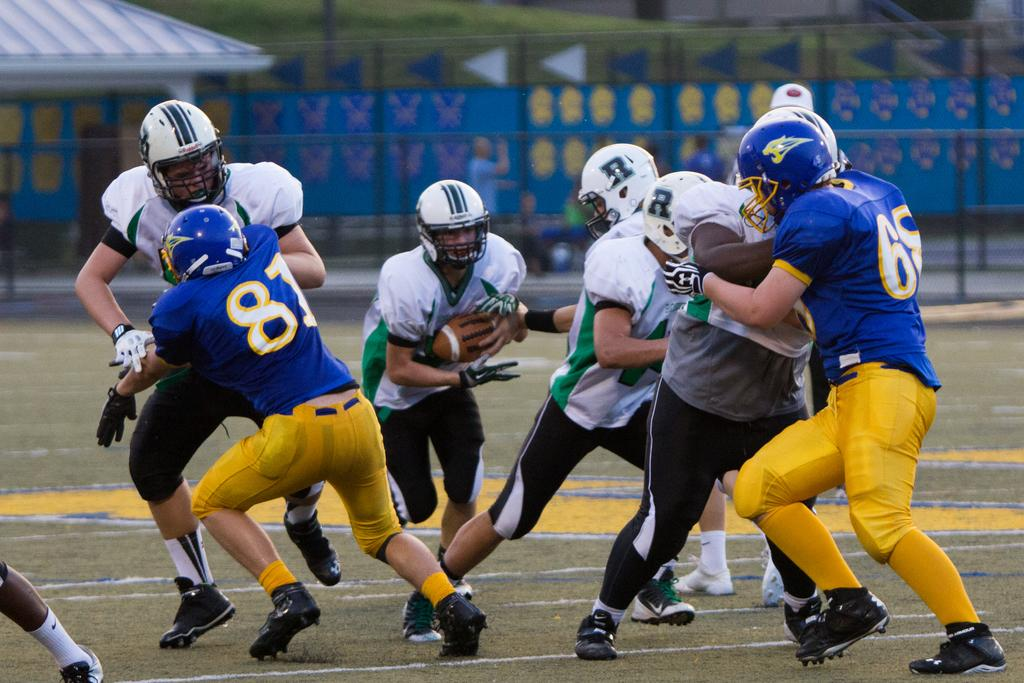What is happening on the ground in the image? There are players on the ground in the image. What can be seen in the distance behind the players? There is a house and fencing in the background of the image. What type of terrain is visible in the background? Grass is present in the background of the image. Can you compare the size of the ants to the players in the image? There are no ants present in the image, so it is not possible to make a comparison. 